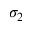Convert formula to latex. <formula><loc_0><loc_0><loc_500><loc_500>\sigma _ { 2 }</formula> 